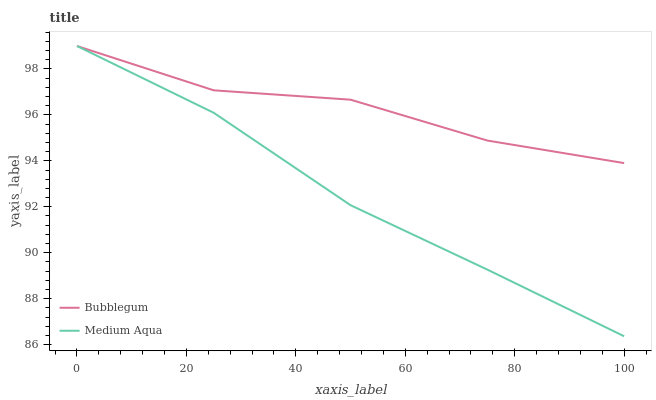Does Medium Aqua have the minimum area under the curve?
Answer yes or no. Yes. Does Bubblegum have the maximum area under the curve?
Answer yes or no. Yes. Does Bubblegum have the minimum area under the curve?
Answer yes or no. No. Is Medium Aqua the smoothest?
Answer yes or no. Yes. Is Bubblegum the roughest?
Answer yes or no. Yes. Is Bubblegum the smoothest?
Answer yes or no. No. Does Medium Aqua have the lowest value?
Answer yes or no. Yes. Does Bubblegum have the lowest value?
Answer yes or no. No. Does Bubblegum have the highest value?
Answer yes or no. Yes. Does Bubblegum intersect Medium Aqua?
Answer yes or no. Yes. Is Bubblegum less than Medium Aqua?
Answer yes or no. No. Is Bubblegum greater than Medium Aqua?
Answer yes or no. No. 